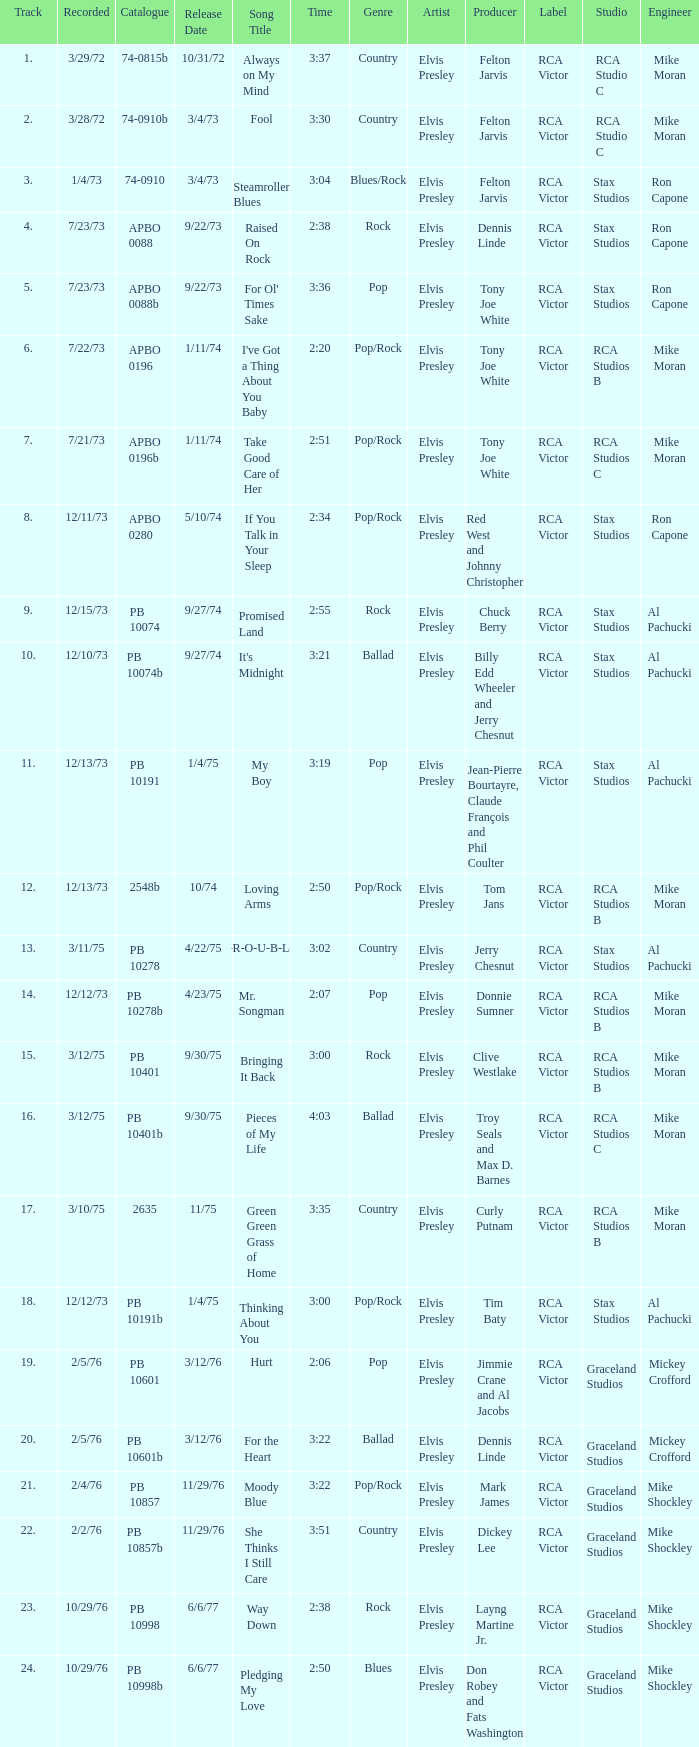I want the sum of tracks for raised on rock 4.0. 